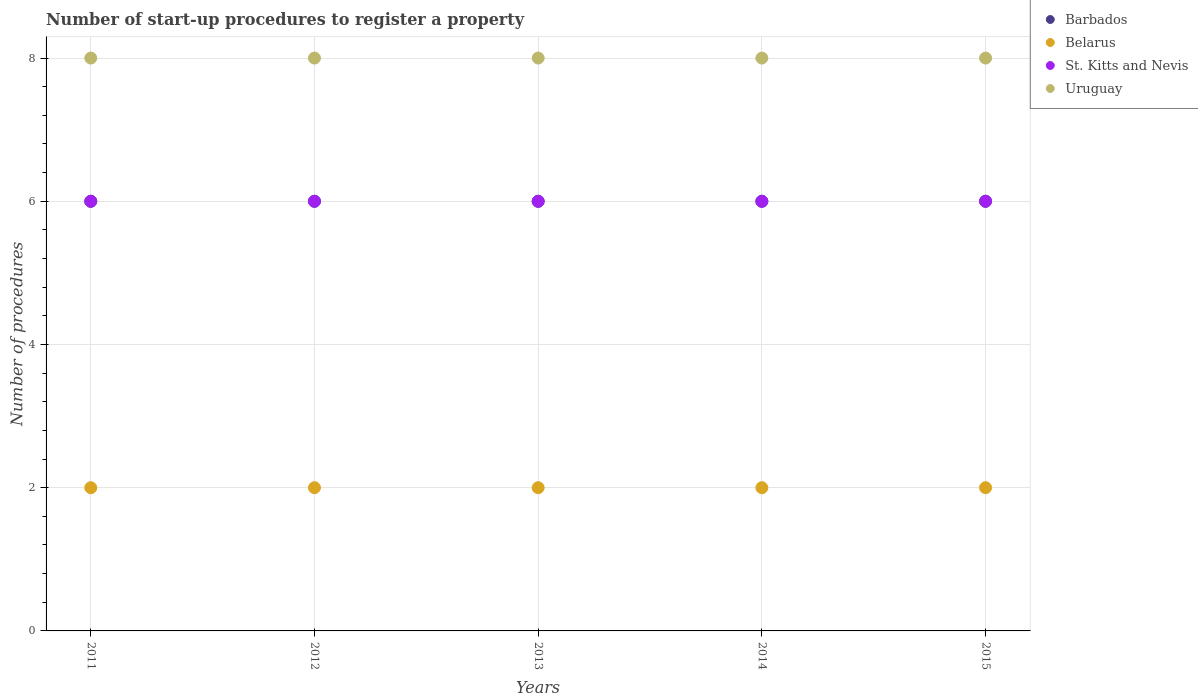How many different coloured dotlines are there?
Offer a very short reply. 4. Across all years, what is the maximum number of procedures required to register a property in Uruguay?
Give a very brief answer. 8. Across all years, what is the minimum number of procedures required to register a property in Belarus?
Provide a succinct answer. 2. What is the total number of procedures required to register a property in Uruguay in the graph?
Offer a terse response. 40. What is the difference between the number of procedures required to register a property in Barbados in 2012 and that in 2015?
Provide a succinct answer. 0. Is the number of procedures required to register a property in Uruguay in 2013 less than that in 2014?
Provide a short and direct response. No. Is the difference between the number of procedures required to register a property in Barbados in 2011 and 2015 greater than the difference between the number of procedures required to register a property in Belarus in 2011 and 2015?
Offer a terse response. No. What is the difference between the highest and the lowest number of procedures required to register a property in Belarus?
Offer a terse response. 0. Is it the case that in every year, the sum of the number of procedures required to register a property in Belarus and number of procedures required to register a property in Barbados  is greater than the sum of number of procedures required to register a property in St. Kitts and Nevis and number of procedures required to register a property in Uruguay?
Your answer should be very brief. Yes. Is the number of procedures required to register a property in St. Kitts and Nevis strictly less than the number of procedures required to register a property in Barbados over the years?
Ensure brevity in your answer.  No. How many dotlines are there?
Provide a short and direct response. 4. What is the difference between two consecutive major ticks on the Y-axis?
Make the answer very short. 2. Are the values on the major ticks of Y-axis written in scientific E-notation?
Your response must be concise. No. Does the graph contain any zero values?
Offer a very short reply. No. Does the graph contain grids?
Your response must be concise. Yes. How many legend labels are there?
Your response must be concise. 4. How are the legend labels stacked?
Your answer should be compact. Vertical. What is the title of the graph?
Ensure brevity in your answer.  Number of start-up procedures to register a property. Does "Mali" appear as one of the legend labels in the graph?
Your answer should be compact. No. What is the label or title of the X-axis?
Your answer should be compact. Years. What is the label or title of the Y-axis?
Keep it short and to the point. Number of procedures. What is the Number of procedures in Belarus in 2011?
Ensure brevity in your answer.  2. What is the Number of procedures of Uruguay in 2012?
Keep it short and to the point. 8. What is the Number of procedures of Barbados in 2014?
Ensure brevity in your answer.  6. What is the Number of procedures in Belarus in 2014?
Ensure brevity in your answer.  2. What is the Number of procedures of St. Kitts and Nevis in 2014?
Provide a succinct answer. 6. What is the Number of procedures in Barbados in 2015?
Your answer should be compact. 6. What is the Number of procedures of St. Kitts and Nevis in 2015?
Your answer should be very brief. 6. What is the Number of procedures of Uruguay in 2015?
Your response must be concise. 8. Across all years, what is the maximum Number of procedures in Barbados?
Your answer should be very brief. 6. Across all years, what is the minimum Number of procedures in Barbados?
Keep it short and to the point. 6. Across all years, what is the minimum Number of procedures of Belarus?
Keep it short and to the point. 2. Across all years, what is the minimum Number of procedures of St. Kitts and Nevis?
Your response must be concise. 6. Across all years, what is the minimum Number of procedures of Uruguay?
Your answer should be very brief. 8. What is the total Number of procedures in Uruguay in the graph?
Your response must be concise. 40. What is the difference between the Number of procedures in Belarus in 2011 and that in 2012?
Offer a terse response. 0. What is the difference between the Number of procedures of Uruguay in 2011 and that in 2012?
Your answer should be compact. 0. What is the difference between the Number of procedures in Barbados in 2011 and that in 2013?
Offer a terse response. 0. What is the difference between the Number of procedures of Belarus in 2011 and that in 2013?
Your response must be concise. 0. What is the difference between the Number of procedures of St. Kitts and Nevis in 2011 and that in 2013?
Provide a succinct answer. 0. What is the difference between the Number of procedures of Belarus in 2011 and that in 2014?
Your answer should be very brief. 0. What is the difference between the Number of procedures in St. Kitts and Nevis in 2011 and that in 2014?
Keep it short and to the point. 0. What is the difference between the Number of procedures in Uruguay in 2011 and that in 2014?
Keep it short and to the point. 0. What is the difference between the Number of procedures of Barbados in 2011 and that in 2015?
Make the answer very short. 0. What is the difference between the Number of procedures in Belarus in 2011 and that in 2015?
Provide a succinct answer. 0. What is the difference between the Number of procedures of Barbados in 2012 and that in 2013?
Provide a succinct answer. 0. What is the difference between the Number of procedures of St. Kitts and Nevis in 2012 and that in 2013?
Provide a short and direct response. 0. What is the difference between the Number of procedures of Barbados in 2012 and that in 2014?
Your answer should be compact. 0. What is the difference between the Number of procedures of Belarus in 2012 and that in 2014?
Provide a short and direct response. 0. What is the difference between the Number of procedures of St. Kitts and Nevis in 2012 and that in 2014?
Your response must be concise. 0. What is the difference between the Number of procedures of Uruguay in 2012 and that in 2014?
Give a very brief answer. 0. What is the difference between the Number of procedures of St. Kitts and Nevis in 2012 and that in 2015?
Keep it short and to the point. 0. What is the difference between the Number of procedures in Uruguay in 2012 and that in 2015?
Your response must be concise. 0. What is the difference between the Number of procedures in Barbados in 2013 and that in 2014?
Provide a succinct answer. 0. What is the difference between the Number of procedures of Belarus in 2013 and that in 2014?
Provide a short and direct response. 0. What is the difference between the Number of procedures in Barbados in 2013 and that in 2015?
Your response must be concise. 0. What is the difference between the Number of procedures of Belarus in 2013 and that in 2015?
Offer a terse response. 0. What is the difference between the Number of procedures of Belarus in 2014 and that in 2015?
Keep it short and to the point. 0. What is the difference between the Number of procedures in St. Kitts and Nevis in 2014 and that in 2015?
Make the answer very short. 0. What is the difference between the Number of procedures of Barbados in 2011 and the Number of procedures of Belarus in 2012?
Make the answer very short. 4. What is the difference between the Number of procedures of Barbados in 2011 and the Number of procedures of Uruguay in 2012?
Your answer should be compact. -2. What is the difference between the Number of procedures of Belarus in 2011 and the Number of procedures of St. Kitts and Nevis in 2012?
Offer a very short reply. -4. What is the difference between the Number of procedures of Belarus in 2011 and the Number of procedures of Uruguay in 2012?
Ensure brevity in your answer.  -6. What is the difference between the Number of procedures in Barbados in 2011 and the Number of procedures in Uruguay in 2013?
Give a very brief answer. -2. What is the difference between the Number of procedures of Belarus in 2011 and the Number of procedures of St. Kitts and Nevis in 2013?
Keep it short and to the point. -4. What is the difference between the Number of procedures in Barbados in 2011 and the Number of procedures in Belarus in 2014?
Your answer should be very brief. 4. What is the difference between the Number of procedures of Barbados in 2011 and the Number of procedures of Uruguay in 2014?
Your response must be concise. -2. What is the difference between the Number of procedures in Barbados in 2011 and the Number of procedures in St. Kitts and Nevis in 2015?
Give a very brief answer. 0. What is the difference between the Number of procedures in Barbados in 2012 and the Number of procedures in Belarus in 2013?
Give a very brief answer. 4. What is the difference between the Number of procedures in Barbados in 2012 and the Number of procedures in St. Kitts and Nevis in 2013?
Give a very brief answer. 0. What is the difference between the Number of procedures in Belarus in 2012 and the Number of procedures in St. Kitts and Nevis in 2013?
Offer a terse response. -4. What is the difference between the Number of procedures of Belarus in 2012 and the Number of procedures of Uruguay in 2013?
Your answer should be very brief. -6. What is the difference between the Number of procedures in St. Kitts and Nevis in 2012 and the Number of procedures in Uruguay in 2013?
Offer a very short reply. -2. What is the difference between the Number of procedures of Belarus in 2012 and the Number of procedures of Uruguay in 2014?
Offer a very short reply. -6. What is the difference between the Number of procedures in Barbados in 2012 and the Number of procedures in St. Kitts and Nevis in 2015?
Keep it short and to the point. 0. What is the difference between the Number of procedures of Belarus in 2012 and the Number of procedures of St. Kitts and Nevis in 2015?
Your answer should be very brief. -4. What is the difference between the Number of procedures in St. Kitts and Nevis in 2012 and the Number of procedures in Uruguay in 2015?
Give a very brief answer. -2. What is the difference between the Number of procedures in Barbados in 2013 and the Number of procedures in Belarus in 2014?
Your answer should be compact. 4. What is the difference between the Number of procedures of Belarus in 2013 and the Number of procedures of Uruguay in 2014?
Offer a very short reply. -6. What is the difference between the Number of procedures in Barbados in 2013 and the Number of procedures in Belarus in 2015?
Your answer should be very brief. 4. What is the difference between the Number of procedures of Barbados in 2013 and the Number of procedures of Uruguay in 2015?
Provide a short and direct response. -2. What is the difference between the Number of procedures of Belarus in 2013 and the Number of procedures of St. Kitts and Nevis in 2015?
Your answer should be compact. -4. What is the difference between the Number of procedures in St. Kitts and Nevis in 2013 and the Number of procedures in Uruguay in 2015?
Provide a succinct answer. -2. What is the difference between the Number of procedures of Barbados in 2014 and the Number of procedures of St. Kitts and Nevis in 2015?
Keep it short and to the point. 0. What is the difference between the Number of procedures in St. Kitts and Nevis in 2014 and the Number of procedures in Uruguay in 2015?
Make the answer very short. -2. What is the average Number of procedures in Belarus per year?
Your answer should be compact. 2. What is the average Number of procedures in Uruguay per year?
Your answer should be compact. 8. In the year 2011, what is the difference between the Number of procedures of Barbados and Number of procedures of Belarus?
Make the answer very short. 4. In the year 2011, what is the difference between the Number of procedures of Belarus and Number of procedures of Uruguay?
Ensure brevity in your answer.  -6. In the year 2012, what is the difference between the Number of procedures of Barbados and Number of procedures of Belarus?
Offer a very short reply. 4. In the year 2012, what is the difference between the Number of procedures in Belarus and Number of procedures in Uruguay?
Provide a succinct answer. -6. In the year 2012, what is the difference between the Number of procedures of St. Kitts and Nevis and Number of procedures of Uruguay?
Your answer should be very brief. -2. In the year 2013, what is the difference between the Number of procedures in Barbados and Number of procedures in Uruguay?
Provide a short and direct response. -2. In the year 2013, what is the difference between the Number of procedures in Belarus and Number of procedures in St. Kitts and Nevis?
Offer a terse response. -4. In the year 2013, what is the difference between the Number of procedures of St. Kitts and Nevis and Number of procedures of Uruguay?
Offer a terse response. -2. In the year 2014, what is the difference between the Number of procedures of Barbados and Number of procedures of St. Kitts and Nevis?
Ensure brevity in your answer.  0. In the year 2015, what is the difference between the Number of procedures in Barbados and Number of procedures in St. Kitts and Nevis?
Your answer should be very brief. 0. In the year 2015, what is the difference between the Number of procedures in Belarus and Number of procedures in St. Kitts and Nevis?
Provide a short and direct response. -4. In the year 2015, what is the difference between the Number of procedures of St. Kitts and Nevis and Number of procedures of Uruguay?
Provide a short and direct response. -2. What is the ratio of the Number of procedures of Barbados in 2011 to that in 2012?
Your answer should be compact. 1. What is the ratio of the Number of procedures in St. Kitts and Nevis in 2011 to that in 2012?
Provide a succinct answer. 1. What is the ratio of the Number of procedures of Uruguay in 2011 to that in 2012?
Keep it short and to the point. 1. What is the ratio of the Number of procedures of Barbados in 2011 to that in 2013?
Your answer should be compact. 1. What is the ratio of the Number of procedures in Belarus in 2011 to that in 2013?
Offer a very short reply. 1. What is the ratio of the Number of procedures in Uruguay in 2011 to that in 2013?
Provide a succinct answer. 1. What is the ratio of the Number of procedures in Barbados in 2011 to that in 2014?
Provide a short and direct response. 1. What is the ratio of the Number of procedures of Barbados in 2011 to that in 2015?
Keep it short and to the point. 1. What is the ratio of the Number of procedures of Barbados in 2012 to that in 2013?
Provide a short and direct response. 1. What is the ratio of the Number of procedures of St. Kitts and Nevis in 2012 to that in 2013?
Keep it short and to the point. 1. What is the ratio of the Number of procedures of Barbados in 2012 to that in 2014?
Your answer should be compact. 1. What is the ratio of the Number of procedures of Uruguay in 2012 to that in 2014?
Keep it short and to the point. 1. What is the ratio of the Number of procedures in St. Kitts and Nevis in 2012 to that in 2015?
Your answer should be very brief. 1. What is the ratio of the Number of procedures of Uruguay in 2012 to that in 2015?
Offer a very short reply. 1. What is the ratio of the Number of procedures in Belarus in 2013 to that in 2014?
Ensure brevity in your answer.  1. What is the ratio of the Number of procedures of St. Kitts and Nevis in 2013 to that in 2014?
Offer a very short reply. 1. What is the ratio of the Number of procedures in Uruguay in 2013 to that in 2014?
Your answer should be very brief. 1. What is the ratio of the Number of procedures in Barbados in 2013 to that in 2015?
Provide a short and direct response. 1. What is the ratio of the Number of procedures of Belarus in 2013 to that in 2015?
Provide a short and direct response. 1. What is the ratio of the Number of procedures in Uruguay in 2013 to that in 2015?
Offer a very short reply. 1. What is the ratio of the Number of procedures in Uruguay in 2014 to that in 2015?
Your answer should be very brief. 1. What is the difference between the highest and the lowest Number of procedures in Barbados?
Keep it short and to the point. 0. What is the difference between the highest and the lowest Number of procedures in St. Kitts and Nevis?
Keep it short and to the point. 0. 